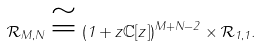Convert formula to latex. <formula><loc_0><loc_0><loc_500><loc_500>\mathcal { R } _ { M , N } \cong ( 1 + z \mathbb { C } [ z ] ) ^ { M + N - 2 } \times \mathcal { R } _ { 1 , 1 } .</formula> 